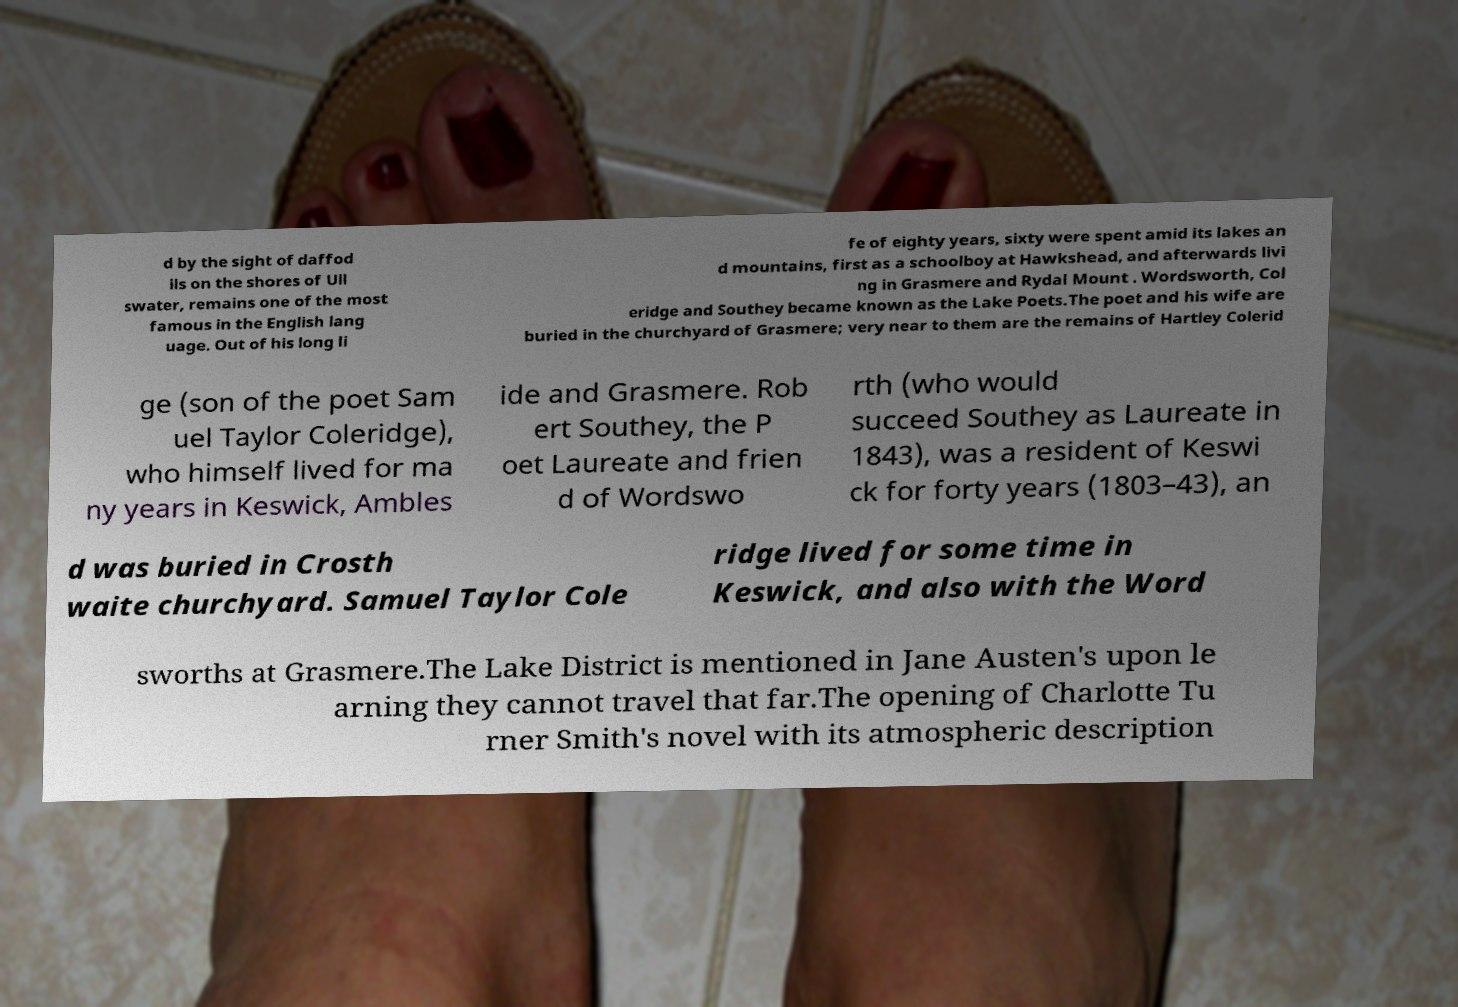There's text embedded in this image that I need extracted. Can you transcribe it verbatim? d by the sight of daffod ils on the shores of Ull swater, remains one of the most famous in the English lang uage. Out of his long li fe of eighty years, sixty were spent amid its lakes an d mountains, first as a schoolboy at Hawkshead, and afterwards livi ng in Grasmere and Rydal Mount . Wordsworth, Col eridge and Southey became known as the Lake Poets.The poet and his wife are buried in the churchyard of Grasmere; very near to them are the remains of Hartley Colerid ge (son of the poet Sam uel Taylor Coleridge), who himself lived for ma ny years in Keswick, Ambles ide and Grasmere. Rob ert Southey, the P oet Laureate and frien d of Wordswo rth (who would succeed Southey as Laureate in 1843), was a resident of Keswi ck for forty years (1803–43), an d was buried in Crosth waite churchyard. Samuel Taylor Cole ridge lived for some time in Keswick, and also with the Word sworths at Grasmere.The Lake District is mentioned in Jane Austen's upon le arning they cannot travel that far.The opening of Charlotte Tu rner Smith's novel with its atmospheric description 